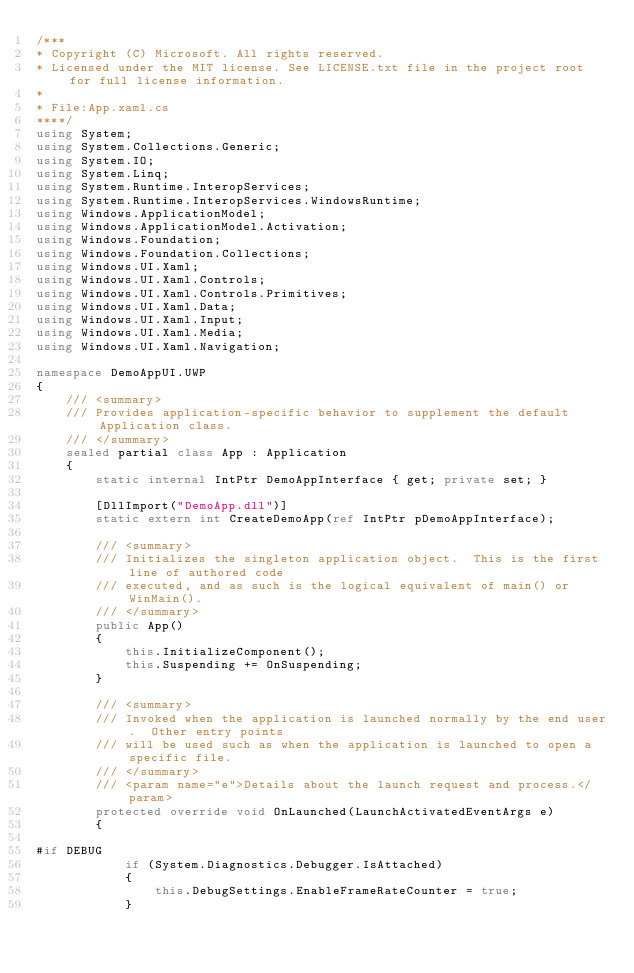Convert code to text. <code><loc_0><loc_0><loc_500><loc_500><_C#_>/***
* Copyright (C) Microsoft. All rights reserved.
* Licensed under the MIT license. See LICENSE.txt file in the project root for full license information.
*
* File:App.xaml.cs
****/
using System;
using System.Collections.Generic;
using System.IO;
using System.Linq;
using System.Runtime.InteropServices;
using System.Runtime.InteropServices.WindowsRuntime;
using Windows.ApplicationModel;
using Windows.ApplicationModel.Activation;
using Windows.Foundation;
using Windows.Foundation.Collections;
using Windows.UI.Xaml;
using Windows.UI.Xaml.Controls;
using Windows.UI.Xaml.Controls.Primitives;
using Windows.UI.Xaml.Data;
using Windows.UI.Xaml.Input;
using Windows.UI.Xaml.Media;
using Windows.UI.Xaml.Navigation;

namespace DemoAppUI.UWP
{
    /// <summary>
    /// Provides application-specific behavior to supplement the default Application class.
    /// </summary>
    sealed partial class App : Application
    {
        static internal IntPtr DemoAppInterface { get; private set; }

        [DllImport("DemoApp.dll")]
        static extern int CreateDemoApp(ref IntPtr pDemoAppInterface);

        /// <summary>
        /// Initializes the singleton application object.  This is the first line of authored code
        /// executed, and as such is the logical equivalent of main() or WinMain().
        /// </summary>
        public App()
        {
            this.InitializeComponent();
            this.Suspending += OnSuspending;
        }

        /// <summary>
        /// Invoked when the application is launched normally by the end user.  Other entry points
        /// will be used such as when the application is launched to open a specific file.
        /// </summary>
        /// <param name="e">Details about the launch request and process.</param>
        protected override void OnLaunched(LaunchActivatedEventArgs e)
        {

#if DEBUG
            if (System.Diagnostics.Debugger.IsAttached)
            {
                this.DebugSettings.EnableFrameRateCounter = true;
            }</code> 